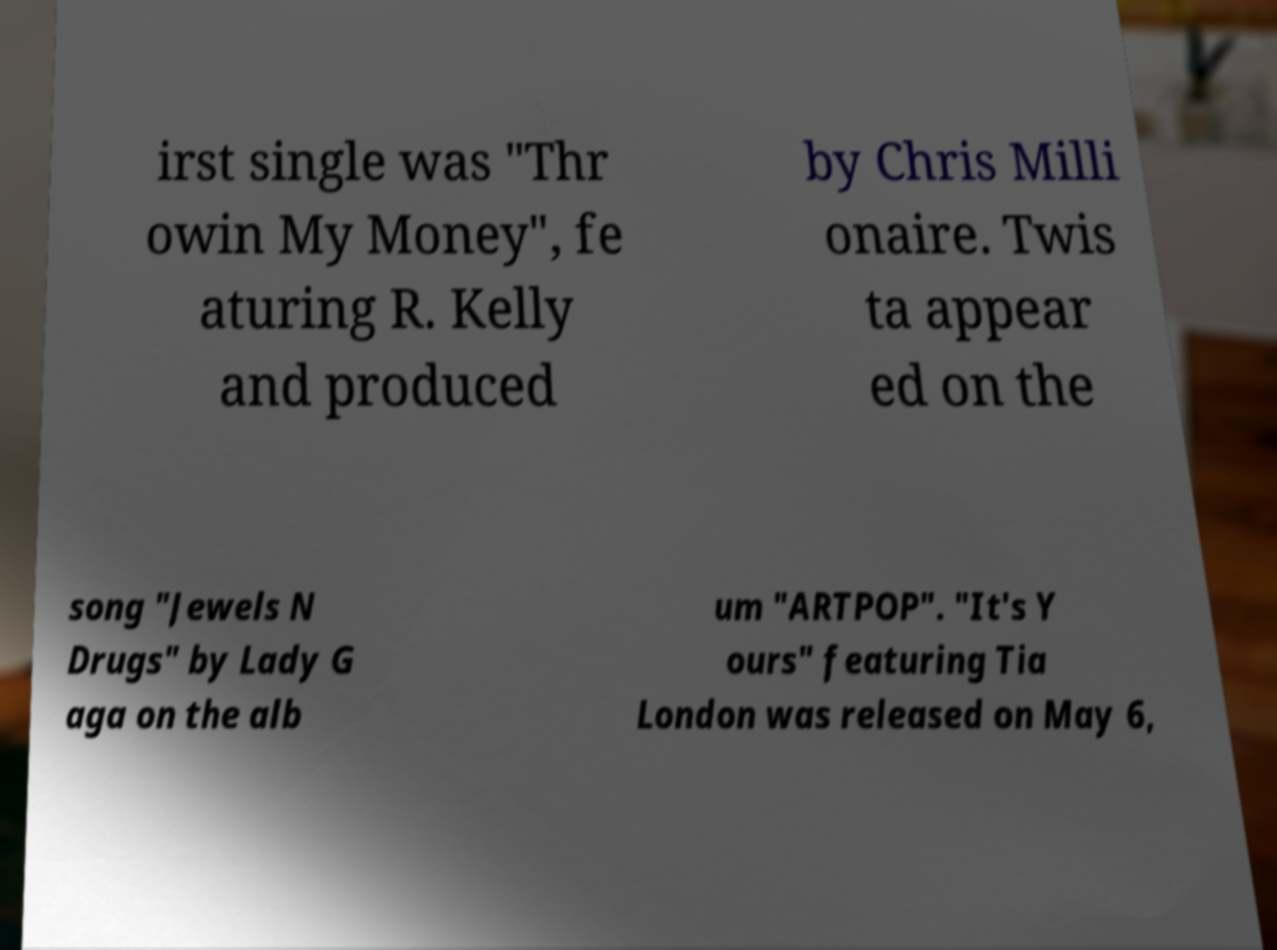Please identify and transcribe the text found in this image. irst single was "Thr owin My Money", fe aturing R. Kelly and produced by Chris Milli onaire. Twis ta appear ed on the song "Jewels N Drugs" by Lady G aga on the alb um "ARTPOP". "It's Y ours" featuring Tia London was released on May 6, 